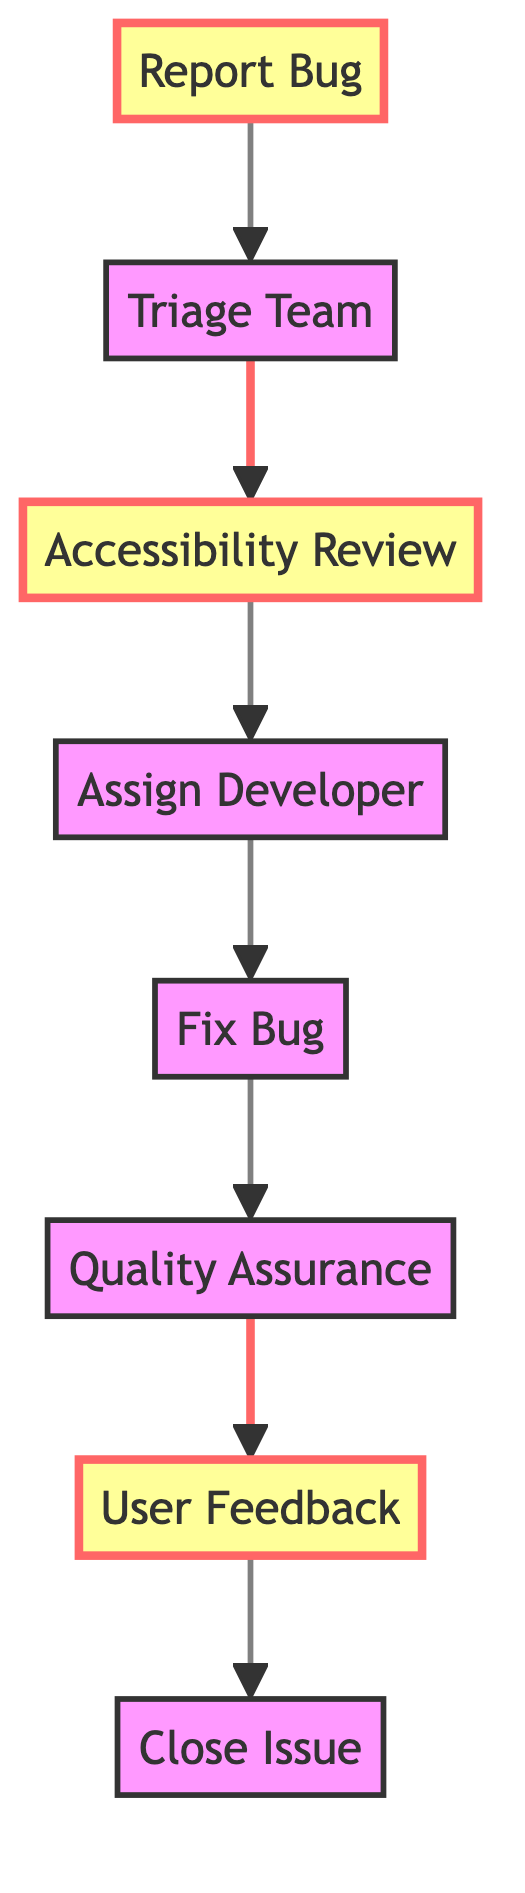What is the first step in the bug reporting workflow? The diagram shows that the first step in the workflow is the "Report Bug" node, which represents the initial submission of a bug report by the user.
Answer: Report Bug How many nodes are there in the diagram? By counting the distinct nodes listed in the diagram, we find there are a total of eight nodes involved in the bug reporting and resolution workflow.
Answer: Eight Which node comes after the "Triage Team"? From the flow of the diagram, the node that follows "Triage Team" is "Accessibility Review," indicating that the next stage after the triage is the review focused on accessibility.
Answer: Accessibility Review What is the final step in the bug reporting process? The last node in the flow of the diagram is "Close Issue," which indicates that this is the final step after obtaining user feedback and confirming the resolution.
Answer: Close Issue Which nodes are highlighted in the diagram? The highlighted nodes are "Report Bug," "Accessibility Review," and "User Feedback." These nodes are emphasized to signify their importance in the process.
Answer: Report Bug, Accessibility Review, User Feedback How many edges connect the nodes in this workflow? By examining the connections between the nodes (edges), we see that there are seven directed edges leading from one node to another in the workflow.
Answer: Seven What is the relationship between the "Quality Assurance" and "User Feedback" nodes? The diagram illustrates a direct connection that shows "Quality Assurance" leads to "User Feedback," indicating that after the QA process, user feedback is obtained to confirm the fix.
Answer: Quality Assurance leads to User Feedback What role does the "Accessibility Review" play in this workflow? The "Accessibility Review" node serves as a critical assessment phase focusing on the inclusivity and accessibility impact of the proposed solution, ensuring the bug fix considers all users.
Answer: Comprehensive assessment for inclusivity Which node must be completed before assigning a developer to fix the bug? According to the flow of the diagram, the "Accessibility Review" must be completed prior to the "Assign Developer" step, as indicated by the direct connection between these nodes.
Answer: Accessibility Review 